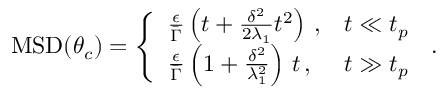Convert formula to latex. <formula><loc_0><loc_0><loc_500><loc_500>\begin{array} { r } { M S D ( \theta _ { c } ) = \left \{ \begin{array} { l l } { \frac { \epsilon } { \bar { \Gamma } } \left ( t + \frac { \delta ^ { 2 } } { 2 \lambda _ { 1 } } t ^ { 2 } \right ) \, , } & { t \ll t _ { p } } \\ { \frac { \epsilon } { \bar { \Gamma } } \left ( 1 + \frac { \delta ^ { 2 } } { \lambda _ { 1 } ^ { 2 } } \right ) \, t \, , } & { t \gg t _ { p } \, } \end{array} . } \end{array}</formula> 